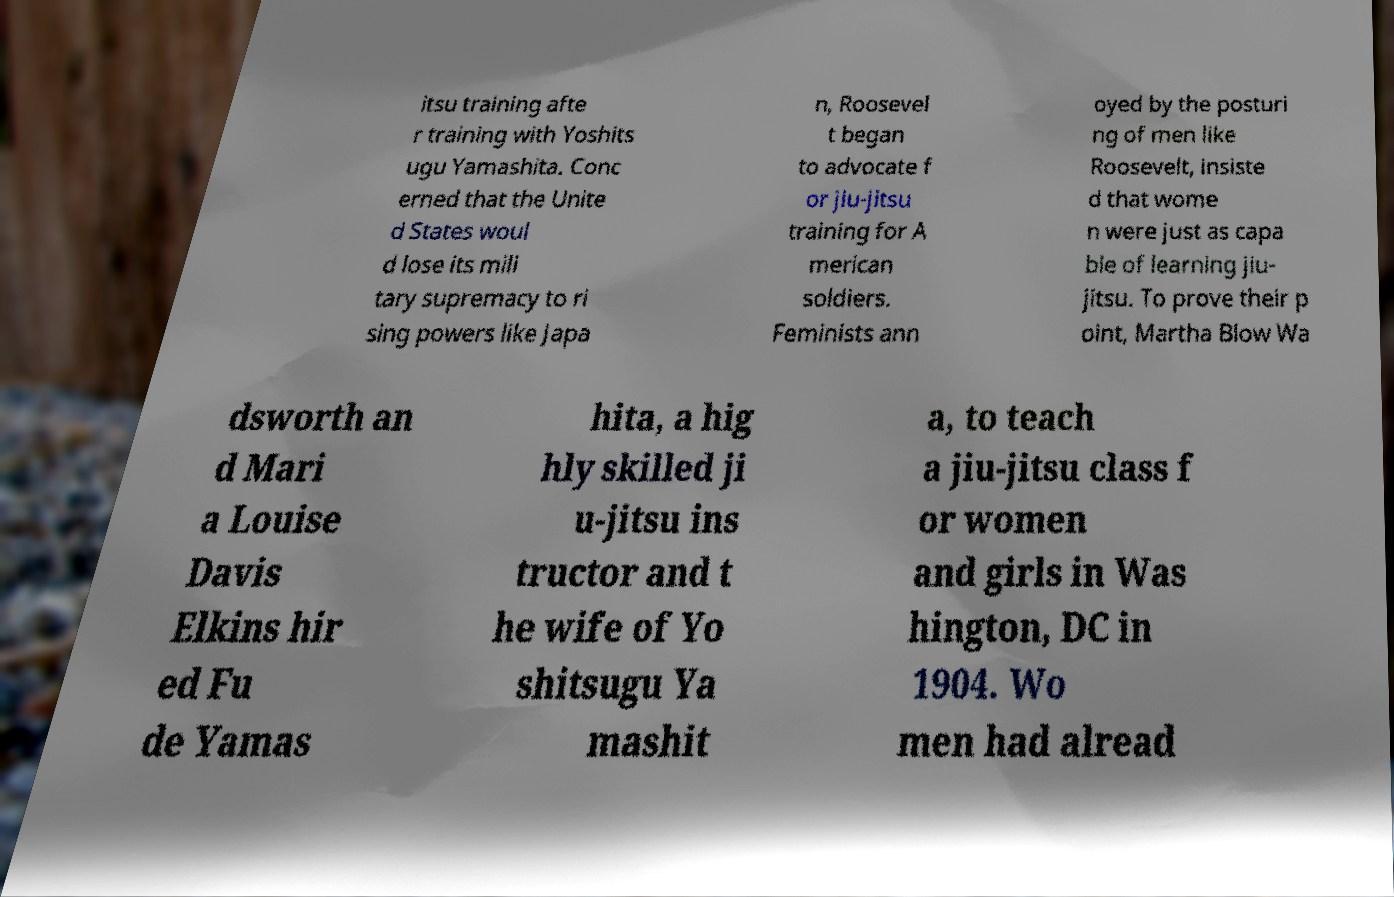There's text embedded in this image that I need extracted. Can you transcribe it verbatim? itsu training afte r training with Yoshits ugu Yamashita. Conc erned that the Unite d States woul d lose its mili tary supremacy to ri sing powers like Japa n, Roosevel t began to advocate f or jiu-jitsu training for A merican soldiers. Feminists ann oyed by the posturi ng of men like Roosevelt, insiste d that wome n were just as capa ble of learning jiu- jitsu. To prove their p oint, Martha Blow Wa dsworth an d Mari a Louise Davis Elkins hir ed Fu de Yamas hita, a hig hly skilled ji u-jitsu ins tructor and t he wife of Yo shitsugu Ya mashit a, to teach a jiu-jitsu class f or women and girls in Was hington, DC in 1904. Wo men had alread 